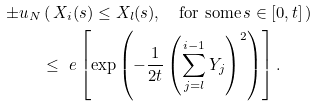<formula> <loc_0><loc_0><loc_500><loc_500>\pm u _ { N } & \left ( \, X _ { i } ( s ) \leq X _ { l } ( s ) , \quad \text {for some} \, s \in [ 0 , t ] \, \right ) \\ & \leq \ e \left [ \exp \left ( - \frac { 1 } { 2 t } \left ( \sum _ { j = l } ^ { i - 1 } Y _ { j } \right ) ^ { 2 } \right ) \right ] .</formula> 